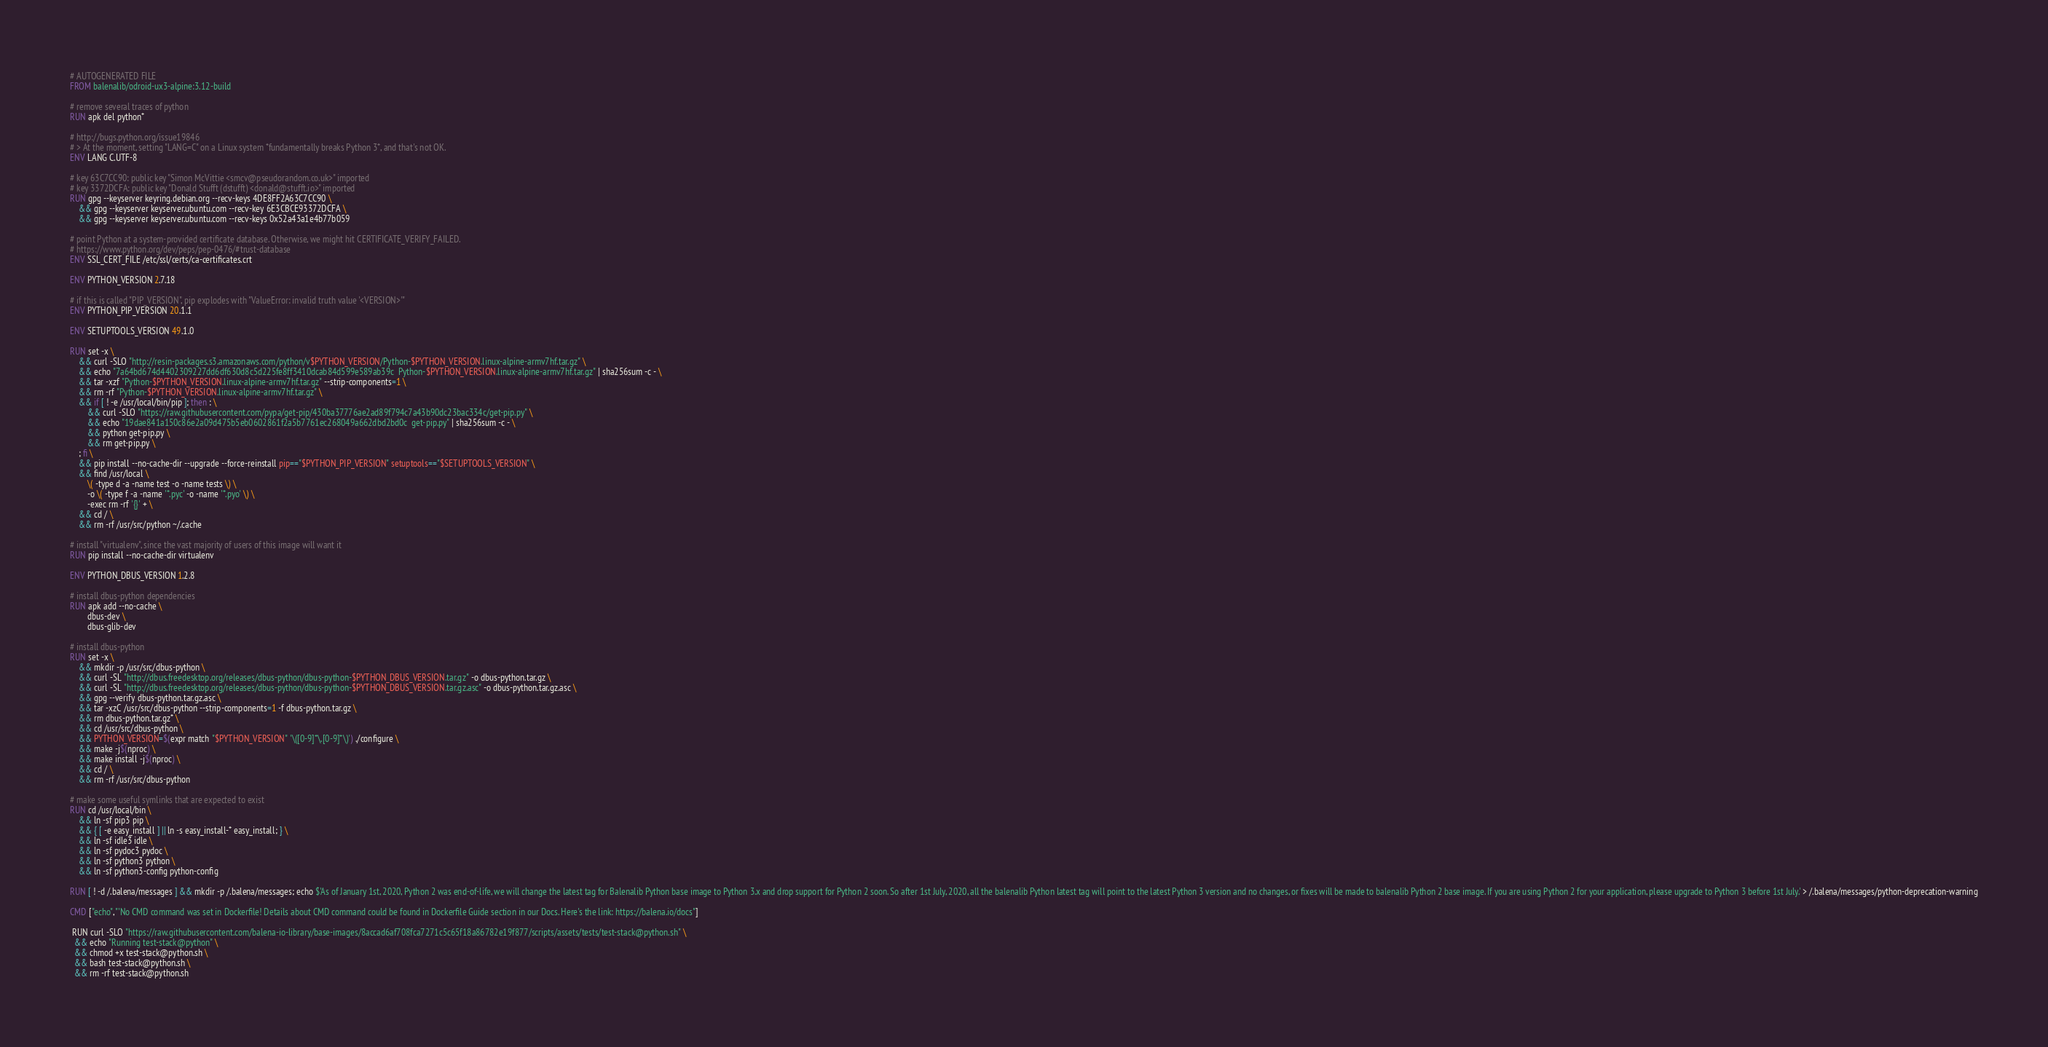<code> <loc_0><loc_0><loc_500><loc_500><_Dockerfile_># AUTOGENERATED FILE
FROM balenalib/odroid-ux3-alpine:3.12-build

# remove several traces of python
RUN apk del python*

# http://bugs.python.org/issue19846
# > At the moment, setting "LANG=C" on a Linux system *fundamentally breaks Python 3*, and that's not OK.
ENV LANG C.UTF-8

# key 63C7CC90: public key "Simon McVittie <smcv@pseudorandom.co.uk>" imported
# key 3372DCFA: public key "Donald Stufft (dstufft) <donald@stufft.io>" imported
RUN gpg --keyserver keyring.debian.org --recv-keys 4DE8FF2A63C7CC90 \
	&& gpg --keyserver keyserver.ubuntu.com --recv-key 6E3CBCE93372DCFA \
	&& gpg --keyserver keyserver.ubuntu.com --recv-keys 0x52a43a1e4b77b059

# point Python at a system-provided certificate database. Otherwise, we might hit CERTIFICATE_VERIFY_FAILED.
# https://www.python.org/dev/peps/pep-0476/#trust-database
ENV SSL_CERT_FILE /etc/ssl/certs/ca-certificates.crt

ENV PYTHON_VERSION 2.7.18

# if this is called "PIP_VERSION", pip explodes with "ValueError: invalid truth value '<VERSION>'"
ENV PYTHON_PIP_VERSION 20.1.1

ENV SETUPTOOLS_VERSION 49.1.0

RUN set -x \
	&& curl -SLO "http://resin-packages.s3.amazonaws.com/python/v$PYTHON_VERSION/Python-$PYTHON_VERSION.linux-alpine-armv7hf.tar.gz" \
	&& echo "7a64bd674d4402309227dd6df630d8c5d225fe8ff3410dcab84d599e589ab39c  Python-$PYTHON_VERSION.linux-alpine-armv7hf.tar.gz" | sha256sum -c - \
	&& tar -xzf "Python-$PYTHON_VERSION.linux-alpine-armv7hf.tar.gz" --strip-components=1 \
	&& rm -rf "Python-$PYTHON_VERSION.linux-alpine-armv7hf.tar.gz" \
	&& if [ ! -e /usr/local/bin/pip ]; then : \
		&& curl -SLO "https://raw.githubusercontent.com/pypa/get-pip/430ba37776ae2ad89f794c7a43b90dc23bac334c/get-pip.py" \
		&& echo "19dae841a150c86e2a09d475b5eb0602861f2a5b7761ec268049a662dbd2bd0c  get-pip.py" | sha256sum -c - \
		&& python get-pip.py \
		&& rm get-pip.py \
	; fi \
	&& pip install --no-cache-dir --upgrade --force-reinstall pip=="$PYTHON_PIP_VERSION" setuptools=="$SETUPTOOLS_VERSION" \
	&& find /usr/local \
		\( -type d -a -name test -o -name tests \) \
		-o \( -type f -a -name '*.pyc' -o -name '*.pyo' \) \
		-exec rm -rf '{}' + \
	&& cd / \
	&& rm -rf /usr/src/python ~/.cache

# install "virtualenv", since the vast majority of users of this image will want it
RUN pip install --no-cache-dir virtualenv

ENV PYTHON_DBUS_VERSION 1.2.8

# install dbus-python dependencies 
RUN apk add --no-cache \
		dbus-dev \
		dbus-glib-dev

# install dbus-python
RUN set -x \
	&& mkdir -p /usr/src/dbus-python \
	&& curl -SL "http://dbus.freedesktop.org/releases/dbus-python/dbus-python-$PYTHON_DBUS_VERSION.tar.gz" -o dbus-python.tar.gz \
	&& curl -SL "http://dbus.freedesktop.org/releases/dbus-python/dbus-python-$PYTHON_DBUS_VERSION.tar.gz.asc" -o dbus-python.tar.gz.asc \
	&& gpg --verify dbus-python.tar.gz.asc \
	&& tar -xzC /usr/src/dbus-python --strip-components=1 -f dbus-python.tar.gz \
	&& rm dbus-python.tar.gz* \
	&& cd /usr/src/dbus-python \
	&& PYTHON_VERSION=$(expr match "$PYTHON_VERSION" '\([0-9]*\.[0-9]*\)') ./configure \
	&& make -j$(nproc) \
	&& make install -j$(nproc) \
	&& cd / \
	&& rm -rf /usr/src/dbus-python

# make some useful symlinks that are expected to exist
RUN cd /usr/local/bin \
	&& ln -sf pip3 pip \
	&& { [ -e easy_install ] || ln -s easy_install-* easy_install; } \
	&& ln -sf idle3 idle \
	&& ln -sf pydoc3 pydoc \
	&& ln -sf python3 python \
	&& ln -sf python3-config python-config

RUN [ ! -d /.balena/messages ] && mkdir -p /.balena/messages; echo $'As of January 1st, 2020, Python 2 was end-of-life, we will change the latest tag for Balenalib Python base image to Python 3.x and drop support for Python 2 soon. So after 1st July, 2020, all the balenalib Python latest tag will point to the latest Python 3 version and no changes, or fixes will be made to balenalib Python 2 base image. If you are using Python 2 for your application, please upgrade to Python 3 before 1st July.' > /.balena/messages/python-deprecation-warning

CMD ["echo","'No CMD command was set in Dockerfile! Details about CMD command could be found in Dockerfile Guide section in our Docs. Here's the link: https://balena.io/docs"]

 RUN curl -SLO "https://raw.githubusercontent.com/balena-io-library/base-images/8accad6af708fca7271c5c65f18a86782e19f877/scripts/assets/tests/test-stack@python.sh" \
  && echo "Running test-stack@python" \
  && chmod +x test-stack@python.sh \
  && bash test-stack@python.sh \
  && rm -rf test-stack@python.sh 
</code> 